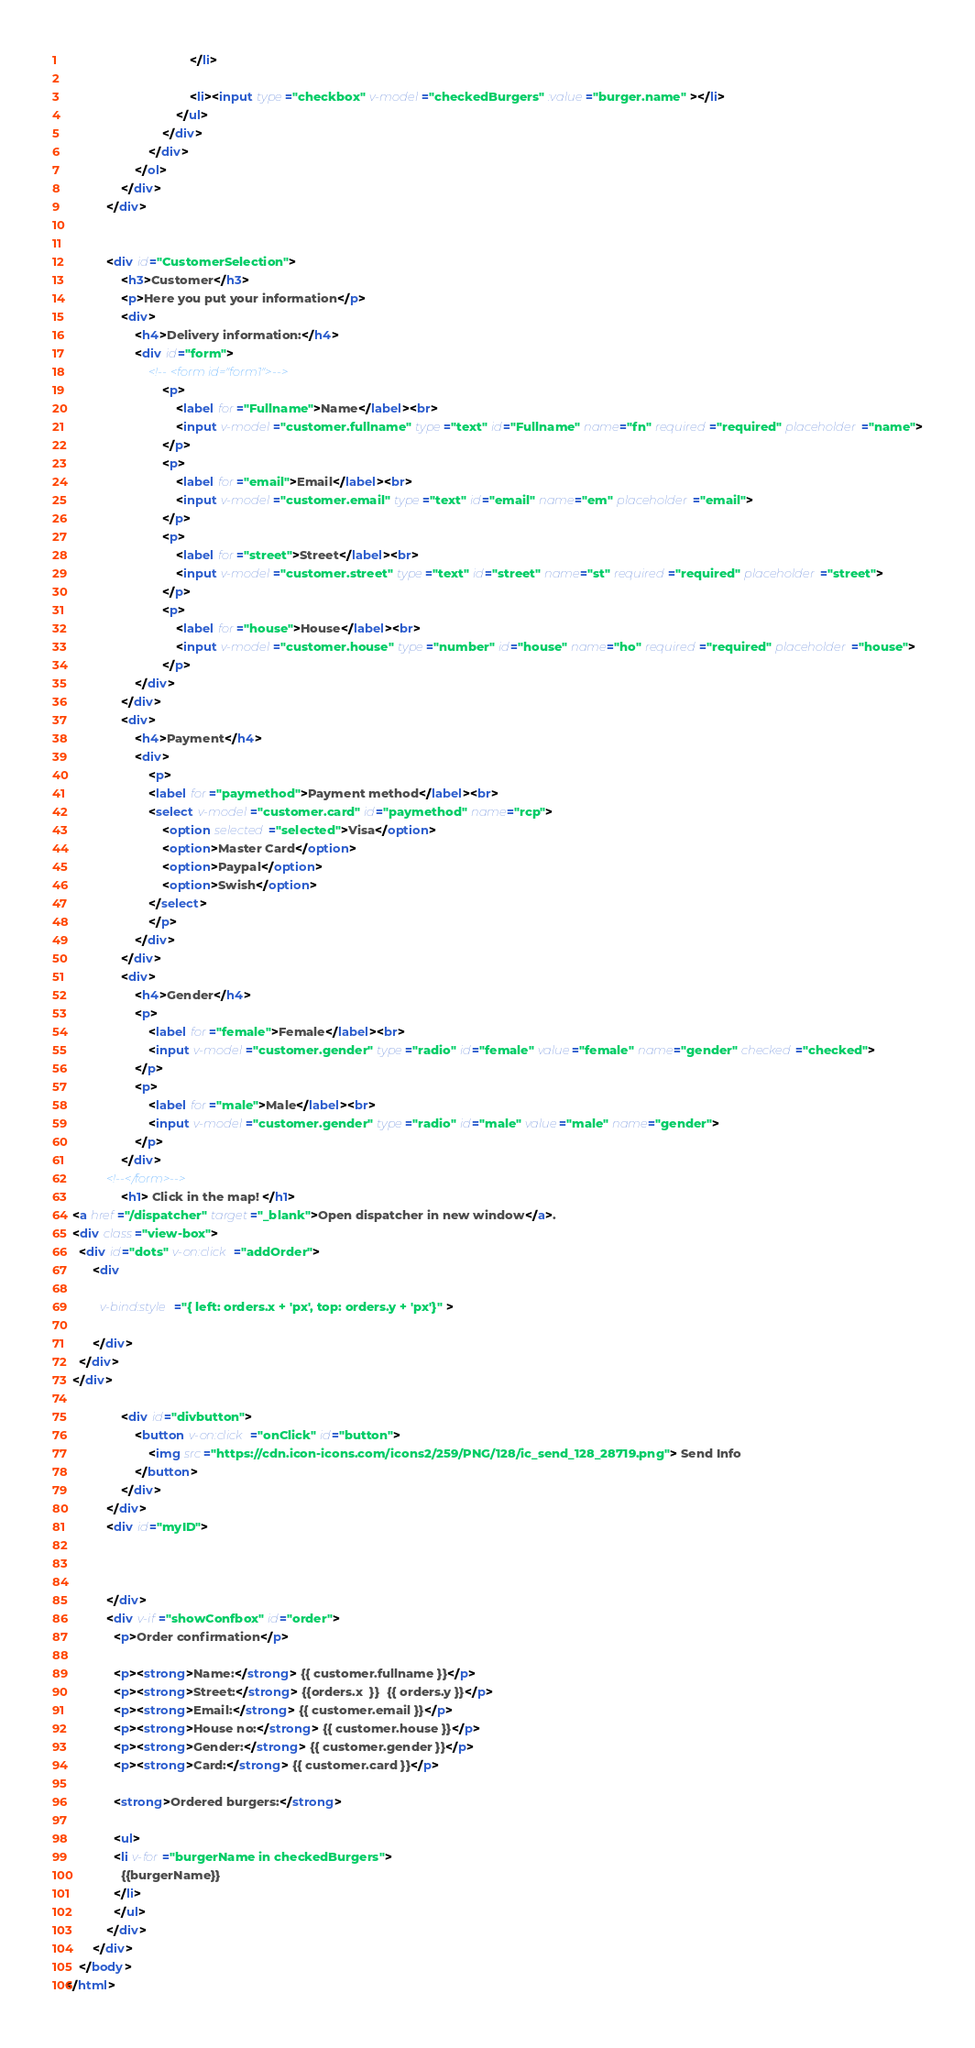Convert code to text. <code><loc_0><loc_0><loc_500><loc_500><_HTML_>									</li>
									
									<li><input type="checkbox" v-model="checkedBurgers" :value="burger.name" ></li>
								</ul>
							</div>
						</div>
					</ol>
				</div>
			</div>


			<div id="CustomerSelection">
				<h3>Customer</h3>
				<p>Here you put your information</p>
				<div>
					<h4>Delivery information:</h4>
					<div id="form">
						<!-- <form id="form1">-->
							<p>
								<label for="Fullname">Name</label><br>
								<input v-model="customer.fullname" type="text" id="Fullname" name="fn" required="required" placeholder="name">
							</p>
							<p>
								<label for="email">Email</label><br>
								<input v-model="customer.email" type="text" id="email" name="em" placeholder="email">
							</p>
							<p>
								<label for="street">Street</label><br>
								<input v-model="customer.street" type="text" id="street" name="st" required="required" placeholder="street">
							</p>
							<p>
								<label for="house">House</label><br>
								<input v-model="customer.house" type="number" id="house" name="ho" required="required" placeholder="house">
							</p>
					</div>
				</div>
				<div>
					<h4>Payment</h4>
					<div>
						<p>
						<label for="paymethod">Payment method</label><br>
						<select v-model="customer.card" id="paymethod" name="rcp">
							<option selected="selected">Visa</option>
							<option>Master Card</option>
							<option>Paypal</option>
							<option>Swish</option>
						</select>
						</p>
					</div>
				</div>
				<div>
					<h4>Gender</h4>
					<p>
						<label for="female">Female</label><br>
						<input v-model="customer.gender" type="radio" id="female" value="female" name="gender" checked="checked">
					</p>
					<p>
						<label for="male">Male</label><br>
						<input v-model="customer.gender" type="radio" id="male" value="male" name="gender">
					</p>
				</div>
			<!--</form>-->
				<h1> Click in the map! </h1>
  <a href="/dispatcher" target="_blank">Open dispatcher in new window</a>.
  <div class="view-box">
    <div id="dots" v-on:click="addOrder">
        <div 
          
          v-bind:style="{ left: orders.x + 'px', top: orders.y + 'px'}" >
          
        </div>
    </div>
  </div>
					
				<div id="divbutton">
					<button v-on:click="onClick" id="button">			
						<img src="https://cdn.icon-icons.com/icons2/259/PNG/128/ic_send_128_28719.png"> Send Info
					</button>
				</div>
			</div>
			<div id="myID">
				
				
				 
			</div>
			<div v-if="showConfbox" id="order">
              <p>Order confirmation</p>
			  
			  <p><strong>Name:</strong> {{ customer.fullname }}</p>
			  <p><strong>Street:</strong> {{orders.x  }}  {{ orders.y }}</p>
			  <p><strong>Email:</strong> {{ customer.email }}</p>
			  <p><strong>House no:</strong> {{ customer.house }}</p>
			  <p><strong>Gender:</strong> {{ customer.gender }}</p>
			  <p><strong>Card:</strong> {{ customer.card }}</p>
			  
			  <strong>Ordered burgers:</strong>
			  
			  <ul>
			  <li v-for="burgerName in checkedBurgers">
				{{burgerName}}
			  </li>
			  </ul>
			</div>
		</div>
	</body>
</html></code> 